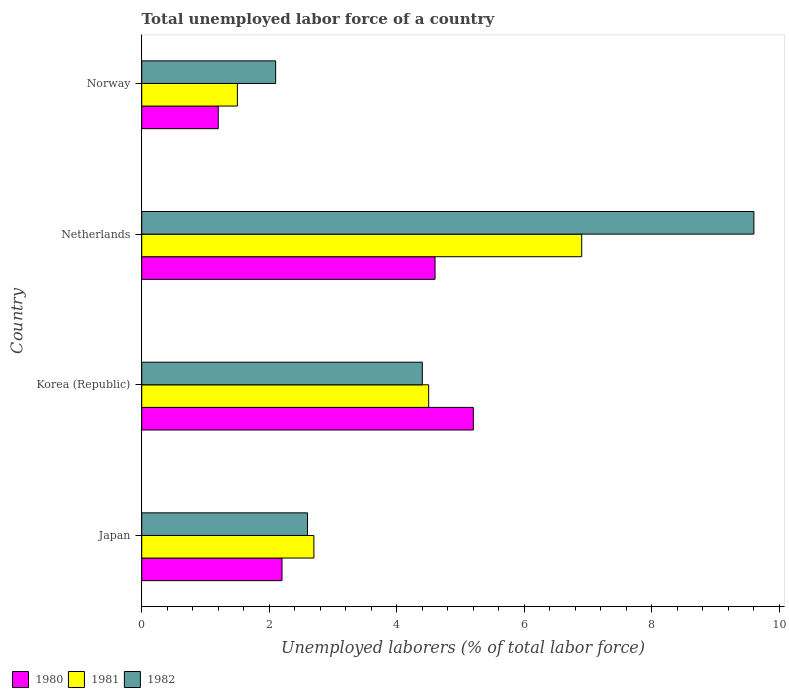Are the number of bars on each tick of the Y-axis equal?
Keep it short and to the point. Yes. How many bars are there on the 3rd tick from the top?
Make the answer very short. 3. What is the total unemployed labor force in 1981 in Korea (Republic)?
Provide a succinct answer. 4.5. Across all countries, what is the maximum total unemployed labor force in 1980?
Your answer should be very brief. 5.2. Across all countries, what is the minimum total unemployed labor force in 1982?
Offer a very short reply. 2.1. In which country was the total unemployed labor force in 1980 maximum?
Provide a succinct answer. Korea (Republic). What is the total total unemployed labor force in 1981 in the graph?
Make the answer very short. 15.6. What is the difference between the total unemployed labor force in 1982 in Japan and that in Norway?
Offer a very short reply. 0.5. What is the difference between the total unemployed labor force in 1981 in Japan and the total unemployed labor force in 1980 in Norway?
Keep it short and to the point. 1.5. What is the average total unemployed labor force in 1980 per country?
Your answer should be compact. 3.3. What is the difference between the total unemployed labor force in 1981 and total unemployed labor force in 1982 in Japan?
Your response must be concise. 0.1. What is the ratio of the total unemployed labor force in 1982 in Netherlands to that in Norway?
Keep it short and to the point. 4.57. Is the difference between the total unemployed labor force in 1981 in Japan and Korea (Republic) greater than the difference between the total unemployed labor force in 1982 in Japan and Korea (Republic)?
Offer a very short reply. Yes. What is the difference between the highest and the second highest total unemployed labor force in 1980?
Your answer should be compact. 0.6. What is the difference between the highest and the lowest total unemployed labor force in 1980?
Your answer should be very brief. 4. In how many countries, is the total unemployed labor force in 1980 greater than the average total unemployed labor force in 1980 taken over all countries?
Provide a short and direct response. 2. Is the sum of the total unemployed labor force in 1981 in Japan and Norway greater than the maximum total unemployed labor force in 1980 across all countries?
Provide a short and direct response. No. What does the 2nd bar from the bottom in Norway represents?
Offer a very short reply. 1981. What is the difference between two consecutive major ticks on the X-axis?
Give a very brief answer. 2. Does the graph contain any zero values?
Your answer should be compact. No. How are the legend labels stacked?
Ensure brevity in your answer.  Horizontal. What is the title of the graph?
Your answer should be compact. Total unemployed labor force of a country. What is the label or title of the X-axis?
Provide a short and direct response. Unemployed laborers (% of total labor force). What is the Unemployed laborers (% of total labor force) of 1980 in Japan?
Provide a succinct answer. 2.2. What is the Unemployed laborers (% of total labor force) in 1981 in Japan?
Offer a very short reply. 2.7. What is the Unemployed laborers (% of total labor force) in 1982 in Japan?
Provide a succinct answer. 2.6. What is the Unemployed laborers (% of total labor force) in 1980 in Korea (Republic)?
Your response must be concise. 5.2. What is the Unemployed laborers (% of total labor force) in 1981 in Korea (Republic)?
Make the answer very short. 4.5. What is the Unemployed laborers (% of total labor force) of 1982 in Korea (Republic)?
Offer a very short reply. 4.4. What is the Unemployed laborers (% of total labor force) in 1980 in Netherlands?
Make the answer very short. 4.6. What is the Unemployed laborers (% of total labor force) in 1981 in Netherlands?
Provide a succinct answer. 6.9. What is the Unemployed laborers (% of total labor force) of 1982 in Netherlands?
Your answer should be compact. 9.6. What is the Unemployed laborers (% of total labor force) of 1980 in Norway?
Your answer should be compact. 1.2. What is the Unemployed laborers (% of total labor force) in 1981 in Norway?
Ensure brevity in your answer.  1.5. What is the Unemployed laborers (% of total labor force) in 1982 in Norway?
Your response must be concise. 2.1. Across all countries, what is the maximum Unemployed laborers (% of total labor force) in 1980?
Make the answer very short. 5.2. Across all countries, what is the maximum Unemployed laborers (% of total labor force) in 1981?
Keep it short and to the point. 6.9. Across all countries, what is the maximum Unemployed laborers (% of total labor force) in 1982?
Ensure brevity in your answer.  9.6. Across all countries, what is the minimum Unemployed laborers (% of total labor force) of 1980?
Provide a short and direct response. 1.2. Across all countries, what is the minimum Unemployed laborers (% of total labor force) of 1981?
Provide a succinct answer. 1.5. Across all countries, what is the minimum Unemployed laborers (% of total labor force) in 1982?
Provide a short and direct response. 2.1. What is the total Unemployed laborers (% of total labor force) in 1981 in the graph?
Keep it short and to the point. 15.6. What is the total Unemployed laborers (% of total labor force) in 1982 in the graph?
Give a very brief answer. 18.7. What is the difference between the Unemployed laborers (% of total labor force) of 1980 in Japan and that in Korea (Republic)?
Ensure brevity in your answer.  -3. What is the difference between the Unemployed laborers (% of total labor force) in 1981 in Japan and that in Netherlands?
Your answer should be very brief. -4.2. What is the difference between the Unemployed laborers (% of total labor force) of 1980 in Japan and that in Norway?
Give a very brief answer. 1. What is the difference between the Unemployed laborers (% of total labor force) in 1982 in Japan and that in Norway?
Offer a very short reply. 0.5. What is the difference between the Unemployed laborers (% of total labor force) of 1981 in Korea (Republic) and that in Netherlands?
Provide a short and direct response. -2.4. What is the difference between the Unemployed laborers (% of total labor force) of 1982 in Korea (Republic) and that in Netherlands?
Ensure brevity in your answer.  -5.2. What is the difference between the Unemployed laborers (% of total labor force) of 1982 in Korea (Republic) and that in Norway?
Offer a very short reply. 2.3. What is the difference between the Unemployed laborers (% of total labor force) in 1981 in Netherlands and that in Norway?
Provide a short and direct response. 5.4. What is the difference between the Unemployed laborers (% of total labor force) in 1980 in Japan and the Unemployed laborers (% of total labor force) in 1982 in Netherlands?
Ensure brevity in your answer.  -7.4. What is the difference between the Unemployed laborers (% of total labor force) in 1981 in Japan and the Unemployed laborers (% of total labor force) in 1982 in Netherlands?
Provide a succinct answer. -6.9. What is the difference between the Unemployed laborers (% of total labor force) in 1980 in Japan and the Unemployed laborers (% of total labor force) in 1982 in Norway?
Your answer should be very brief. 0.1. What is the difference between the Unemployed laborers (% of total labor force) of 1981 in Japan and the Unemployed laborers (% of total labor force) of 1982 in Norway?
Provide a succinct answer. 0.6. What is the difference between the Unemployed laborers (% of total labor force) in 1980 in Korea (Republic) and the Unemployed laborers (% of total labor force) in 1981 in Netherlands?
Your answer should be very brief. -1.7. What is the difference between the Unemployed laborers (% of total labor force) in 1980 in Korea (Republic) and the Unemployed laborers (% of total labor force) in 1981 in Norway?
Your answer should be compact. 3.7. What is the difference between the Unemployed laborers (% of total labor force) in 1980 in Netherlands and the Unemployed laborers (% of total labor force) in 1982 in Norway?
Your answer should be very brief. 2.5. What is the difference between the Unemployed laborers (% of total labor force) in 1981 in Netherlands and the Unemployed laborers (% of total labor force) in 1982 in Norway?
Provide a short and direct response. 4.8. What is the average Unemployed laborers (% of total labor force) in 1980 per country?
Offer a terse response. 3.3. What is the average Unemployed laborers (% of total labor force) of 1981 per country?
Provide a short and direct response. 3.9. What is the average Unemployed laborers (% of total labor force) in 1982 per country?
Provide a short and direct response. 4.67. What is the difference between the Unemployed laborers (% of total labor force) in 1980 and Unemployed laborers (% of total labor force) in 1982 in Japan?
Ensure brevity in your answer.  -0.4. What is the difference between the Unemployed laborers (% of total labor force) of 1980 and Unemployed laborers (% of total labor force) of 1981 in Korea (Republic)?
Keep it short and to the point. 0.7. What is the difference between the Unemployed laborers (% of total labor force) in 1981 and Unemployed laborers (% of total labor force) in 1982 in Korea (Republic)?
Your answer should be compact. 0.1. What is the difference between the Unemployed laborers (% of total labor force) of 1980 and Unemployed laborers (% of total labor force) of 1982 in Netherlands?
Offer a terse response. -5. What is the difference between the Unemployed laborers (% of total labor force) of 1980 and Unemployed laborers (% of total labor force) of 1982 in Norway?
Your response must be concise. -0.9. What is the ratio of the Unemployed laborers (% of total labor force) in 1980 in Japan to that in Korea (Republic)?
Provide a succinct answer. 0.42. What is the ratio of the Unemployed laborers (% of total labor force) of 1981 in Japan to that in Korea (Republic)?
Provide a short and direct response. 0.6. What is the ratio of the Unemployed laborers (% of total labor force) of 1982 in Japan to that in Korea (Republic)?
Provide a short and direct response. 0.59. What is the ratio of the Unemployed laborers (% of total labor force) of 1980 in Japan to that in Netherlands?
Keep it short and to the point. 0.48. What is the ratio of the Unemployed laborers (% of total labor force) in 1981 in Japan to that in Netherlands?
Your answer should be compact. 0.39. What is the ratio of the Unemployed laborers (% of total labor force) in 1982 in Japan to that in Netherlands?
Your answer should be compact. 0.27. What is the ratio of the Unemployed laborers (% of total labor force) in 1980 in Japan to that in Norway?
Keep it short and to the point. 1.83. What is the ratio of the Unemployed laborers (% of total labor force) of 1981 in Japan to that in Norway?
Your response must be concise. 1.8. What is the ratio of the Unemployed laborers (% of total labor force) of 1982 in Japan to that in Norway?
Keep it short and to the point. 1.24. What is the ratio of the Unemployed laborers (% of total labor force) of 1980 in Korea (Republic) to that in Netherlands?
Ensure brevity in your answer.  1.13. What is the ratio of the Unemployed laborers (% of total labor force) in 1981 in Korea (Republic) to that in Netherlands?
Your response must be concise. 0.65. What is the ratio of the Unemployed laborers (% of total labor force) of 1982 in Korea (Republic) to that in Netherlands?
Make the answer very short. 0.46. What is the ratio of the Unemployed laborers (% of total labor force) in 1980 in Korea (Republic) to that in Norway?
Ensure brevity in your answer.  4.33. What is the ratio of the Unemployed laborers (% of total labor force) of 1982 in Korea (Republic) to that in Norway?
Give a very brief answer. 2.1. What is the ratio of the Unemployed laborers (% of total labor force) in 1980 in Netherlands to that in Norway?
Ensure brevity in your answer.  3.83. What is the ratio of the Unemployed laborers (% of total labor force) in 1981 in Netherlands to that in Norway?
Offer a terse response. 4.6. What is the ratio of the Unemployed laborers (% of total labor force) of 1982 in Netherlands to that in Norway?
Your response must be concise. 4.57. What is the difference between the highest and the second highest Unemployed laborers (% of total labor force) in 1982?
Your answer should be compact. 5.2. What is the difference between the highest and the lowest Unemployed laborers (% of total labor force) in 1981?
Provide a succinct answer. 5.4. What is the difference between the highest and the lowest Unemployed laborers (% of total labor force) in 1982?
Your answer should be compact. 7.5. 